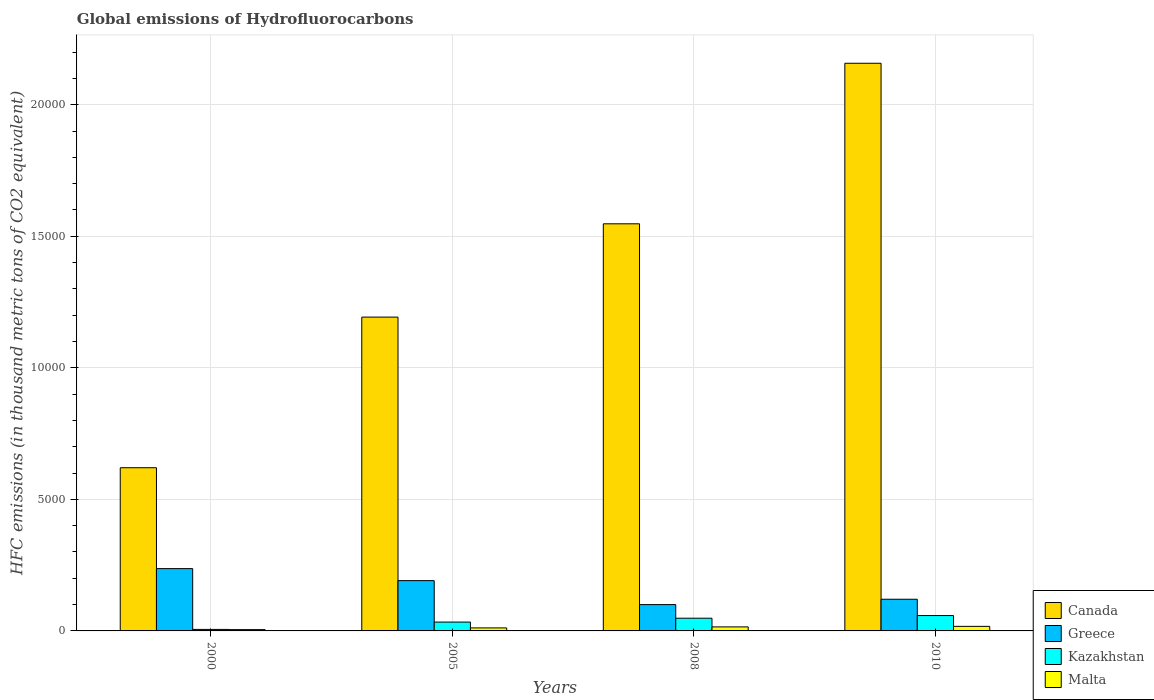Are the number of bars per tick equal to the number of legend labels?
Offer a terse response. Yes. Are the number of bars on each tick of the X-axis equal?
Offer a terse response. Yes. How many bars are there on the 3rd tick from the left?
Your answer should be very brief. 4. How many bars are there on the 2nd tick from the right?
Give a very brief answer. 4. In how many cases, is the number of bars for a given year not equal to the number of legend labels?
Give a very brief answer. 0. What is the global emissions of Hydrofluorocarbons in Kazakhstan in 2008?
Offer a terse response. 482.9. Across all years, what is the maximum global emissions of Hydrofluorocarbons in Canada?
Your response must be concise. 2.16e+04. Across all years, what is the minimum global emissions of Hydrofluorocarbons in Greece?
Your answer should be very brief. 1000.3. In which year was the global emissions of Hydrofluorocarbons in Greece maximum?
Offer a very short reply. 2000. In which year was the global emissions of Hydrofluorocarbons in Canada minimum?
Offer a terse response. 2000. What is the total global emissions of Hydrofluorocarbons in Kazakhstan in the graph?
Your response must be concise. 1461.1. What is the difference between the global emissions of Hydrofluorocarbons in Malta in 2005 and that in 2008?
Provide a succinct answer. -39. What is the difference between the global emissions of Hydrofluorocarbons in Canada in 2008 and the global emissions of Hydrofluorocarbons in Greece in 2000?
Offer a very short reply. 1.31e+04. What is the average global emissions of Hydrofluorocarbons in Malta per year?
Provide a short and direct response. 122.6. In the year 2000, what is the difference between the global emissions of Hydrofluorocarbons in Greece and global emissions of Hydrofluorocarbons in Malta?
Provide a short and direct response. 2318.4. What is the ratio of the global emissions of Hydrofluorocarbons in Kazakhstan in 2005 to that in 2008?
Your answer should be very brief. 0.7. Is the difference between the global emissions of Hydrofluorocarbons in Greece in 2000 and 2008 greater than the difference between the global emissions of Hydrofluorocarbons in Malta in 2000 and 2008?
Your response must be concise. Yes. What is the difference between the highest and the second highest global emissions of Hydrofluorocarbons in Malta?
Make the answer very short. 19.8. What is the difference between the highest and the lowest global emissions of Hydrofluorocarbons in Canada?
Give a very brief answer. 1.54e+04. In how many years, is the global emissions of Hydrofluorocarbons in Greece greater than the average global emissions of Hydrofluorocarbons in Greece taken over all years?
Offer a terse response. 2. Is the sum of the global emissions of Hydrofluorocarbons in Malta in 2005 and 2008 greater than the maximum global emissions of Hydrofluorocarbons in Canada across all years?
Offer a very short reply. No. What does the 4th bar from the left in 2005 represents?
Ensure brevity in your answer.  Malta. What does the 4th bar from the right in 2010 represents?
Ensure brevity in your answer.  Canada. Is it the case that in every year, the sum of the global emissions of Hydrofluorocarbons in Malta and global emissions of Hydrofluorocarbons in Greece is greater than the global emissions of Hydrofluorocarbons in Canada?
Offer a very short reply. No. How many bars are there?
Make the answer very short. 16. How many years are there in the graph?
Your answer should be compact. 4. Are the values on the major ticks of Y-axis written in scientific E-notation?
Your answer should be very brief. No. Does the graph contain any zero values?
Give a very brief answer. No. Where does the legend appear in the graph?
Make the answer very short. Bottom right. What is the title of the graph?
Offer a terse response. Global emissions of Hydrofluorocarbons. What is the label or title of the X-axis?
Provide a short and direct response. Years. What is the label or title of the Y-axis?
Your response must be concise. HFC emissions (in thousand metric tons of CO2 equivalent). What is the HFC emissions (in thousand metric tons of CO2 equivalent) of Canada in 2000?
Provide a short and direct response. 6202.8. What is the HFC emissions (in thousand metric tons of CO2 equivalent) in Greece in 2000?
Your answer should be very brief. 2368.4. What is the HFC emissions (in thousand metric tons of CO2 equivalent) of Kazakhstan in 2000?
Make the answer very short. 57.5. What is the HFC emissions (in thousand metric tons of CO2 equivalent) of Canada in 2005?
Keep it short and to the point. 1.19e+04. What is the HFC emissions (in thousand metric tons of CO2 equivalent) of Greece in 2005?
Give a very brief answer. 1911.4. What is the HFC emissions (in thousand metric tons of CO2 equivalent) of Kazakhstan in 2005?
Offer a terse response. 336.7. What is the HFC emissions (in thousand metric tons of CO2 equivalent) of Malta in 2005?
Your answer should be compact. 114.2. What is the HFC emissions (in thousand metric tons of CO2 equivalent) in Canada in 2008?
Provide a succinct answer. 1.55e+04. What is the HFC emissions (in thousand metric tons of CO2 equivalent) in Greece in 2008?
Provide a succinct answer. 1000.3. What is the HFC emissions (in thousand metric tons of CO2 equivalent) in Kazakhstan in 2008?
Provide a succinct answer. 482.9. What is the HFC emissions (in thousand metric tons of CO2 equivalent) of Malta in 2008?
Provide a succinct answer. 153.2. What is the HFC emissions (in thousand metric tons of CO2 equivalent) in Canada in 2010?
Keep it short and to the point. 2.16e+04. What is the HFC emissions (in thousand metric tons of CO2 equivalent) of Greece in 2010?
Give a very brief answer. 1204. What is the HFC emissions (in thousand metric tons of CO2 equivalent) in Kazakhstan in 2010?
Provide a short and direct response. 584. What is the HFC emissions (in thousand metric tons of CO2 equivalent) of Malta in 2010?
Make the answer very short. 173. Across all years, what is the maximum HFC emissions (in thousand metric tons of CO2 equivalent) of Canada?
Your answer should be compact. 2.16e+04. Across all years, what is the maximum HFC emissions (in thousand metric tons of CO2 equivalent) in Greece?
Provide a short and direct response. 2368.4. Across all years, what is the maximum HFC emissions (in thousand metric tons of CO2 equivalent) in Kazakhstan?
Keep it short and to the point. 584. Across all years, what is the maximum HFC emissions (in thousand metric tons of CO2 equivalent) in Malta?
Provide a short and direct response. 173. Across all years, what is the minimum HFC emissions (in thousand metric tons of CO2 equivalent) of Canada?
Your answer should be very brief. 6202.8. Across all years, what is the minimum HFC emissions (in thousand metric tons of CO2 equivalent) in Greece?
Keep it short and to the point. 1000.3. Across all years, what is the minimum HFC emissions (in thousand metric tons of CO2 equivalent) in Kazakhstan?
Give a very brief answer. 57.5. Across all years, what is the minimum HFC emissions (in thousand metric tons of CO2 equivalent) of Malta?
Keep it short and to the point. 50. What is the total HFC emissions (in thousand metric tons of CO2 equivalent) of Canada in the graph?
Provide a short and direct response. 5.52e+04. What is the total HFC emissions (in thousand metric tons of CO2 equivalent) of Greece in the graph?
Ensure brevity in your answer.  6484.1. What is the total HFC emissions (in thousand metric tons of CO2 equivalent) in Kazakhstan in the graph?
Provide a succinct answer. 1461.1. What is the total HFC emissions (in thousand metric tons of CO2 equivalent) of Malta in the graph?
Provide a short and direct response. 490.4. What is the difference between the HFC emissions (in thousand metric tons of CO2 equivalent) of Canada in 2000 and that in 2005?
Your response must be concise. -5725.6. What is the difference between the HFC emissions (in thousand metric tons of CO2 equivalent) in Greece in 2000 and that in 2005?
Offer a terse response. 457. What is the difference between the HFC emissions (in thousand metric tons of CO2 equivalent) in Kazakhstan in 2000 and that in 2005?
Your answer should be very brief. -279.2. What is the difference between the HFC emissions (in thousand metric tons of CO2 equivalent) of Malta in 2000 and that in 2005?
Provide a succinct answer. -64.2. What is the difference between the HFC emissions (in thousand metric tons of CO2 equivalent) in Canada in 2000 and that in 2008?
Provide a short and direct response. -9272. What is the difference between the HFC emissions (in thousand metric tons of CO2 equivalent) of Greece in 2000 and that in 2008?
Your response must be concise. 1368.1. What is the difference between the HFC emissions (in thousand metric tons of CO2 equivalent) in Kazakhstan in 2000 and that in 2008?
Provide a succinct answer. -425.4. What is the difference between the HFC emissions (in thousand metric tons of CO2 equivalent) of Malta in 2000 and that in 2008?
Offer a very short reply. -103.2. What is the difference between the HFC emissions (in thousand metric tons of CO2 equivalent) in Canada in 2000 and that in 2010?
Your answer should be compact. -1.54e+04. What is the difference between the HFC emissions (in thousand metric tons of CO2 equivalent) of Greece in 2000 and that in 2010?
Provide a succinct answer. 1164.4. What is the difference between the HFC emissions (in thousand metric tons of CO2 equivalent) in Kazakhstan in 2000 and that in 2010?
Offer a terse response. -526.5. What is the difference between the HFC emissions (in thousand metric tons of CO2 equivalent) in Malta in 2000 and that in 2010?
Offer a very short reply. -123. What is the difference between the HFC emissions (in thousand metric tons of CO2 equivalent) in Canada in 2005 and that in 2008?
Offer a terse response. -3546.4. What is the difference between the HFC emissions (in thousand metric tons of CO2 equivalent) in Greece in 2005 and that in 2008?
Offer a terse response. 911.1. What is the difference between the HFC emissions (in thousand metric tons of CO2 equivalent) in Kazakhstan in 2005 and that in 2008?
Provide a succinct answer. -146.2. What is the difference between the HFC emissions (in thousand metric tons of CO2 equivalent) of Malta in 2005 and that in 2008?
Provide a short and direct response. -39. What is the difference between the HFC emissions (in thousand metric tons of CO2 equivalent) of Canada in 2005 and that in 2010?
Your answer should be very brief. -9648.6. What is the difference between the HFC emissions (in thousand metric tons of CO2 equivalent) in Greece in 2005 and that in 2010?
Make the answer very short. 707.4. What is the difference between the HFC emissions (in thousand metric tons of CO2 equivalent) in Kazakhstan in 2005 and that in 2010?
Your answer should be very brief. -247.3. What is the difference between the HFC emissions (in thousand metric tons of CO2 equivalent) in Malta in 2005 and that in 2010?
Make the answer very short. -58.8. What is the difference between the HFC emissions (in thousand metric tons of CO2 equivalent) in Canada in 2008 and that in 2010?
Ensure brevity in your answer.  -6102.2. What is the difference between the HFC emissions (in thousand metric tons of CO2 equivalent) in Greece in 2008 and that in 2010?
Provide a succinct answer. -203.7. What is the difference between the HFC emissions (in thousand metric tons of CO2 equivalent) in Kazakhstan in 2008 and that in 2010?
Make the answer very short. -101.1. What is the difference between the HFC emissions (in thousand metric tons of CO2 equivalent) of Malta in 2008 and that in 2010?
Provide a succinct answer. -19.8. What is the difference between the HFC emissions (in thousand metric tons of CO2 equivalent) of Canada in 2000 and the HFC emissions (in thousand metric tons of CO2 equivalent) of Greece in 2005?
Offer a very short reply. 4291.4. What is the difference between the HFC emissions (in thousand metric tons of CO2 equivalent) of Canada in 2000 and the HFC emissions (in thousand metric tons of CO2 equivalent) of Kazakhstan in 2005?
Provide a short and direct response. 5866.1. What is the difference between the HFC emissions (in thousand metric tons of CO2 equivalent) of Canada in 2000 and the HFC emissions (in thousand metric tons of CO2 equivalent) of Malta in 2005?
Provide a succinct answer. 6088.6. What is the difference between the HFC emissions (in thousand metric tons of CO2 equivalent) of Greece in 2000 and the HFC emissions (in thousand metric tons of CO2 equivalent) of Kazakhstan in 2005?
Provide a succinct answer. 2031.7. What is the difference between the HFC emissions (in thousand metric tons of CO2 equivalent) of Greece in 2000 and the HFC emissions (in thousand metric tons of CO2 equivalent) of Malta in 2005?
Offer a very short reply. 2254.2. What is the difference between the HFC emissions (in thousand metric tons of CO2 equivalent) in Kazakhstan in 2000 and the HFC emissions (in thousand metric tons of CO2 equivalent) in Malta in 2005?
Your answer should be very brief. -56.7. What is the difference between the HFC emissions (in thousand metric tons of CO2 equivalent) of Canada in 2000 and the HFC emissions (in thousand metric tons of CO2 equivalent) of Greece in 2008?
Keep it short and to the point. 5202.5. What is the difference between the HFC emissions (in thousand metric tons of CO2 equivalent) in Canada in 2000 and the HFC emissions (in thousand metric tons of CO2 equivalent) in Kazakhstan in 2008?
Your response must be concise. 5719.9. What is the difference between the HFC emissions (in thousand metric tons of CO2 equivalent) of Canada in 2000 and the HFC emissions (in thousand metric tons of CO2 equivalent) of Malta in 2008?
Give a very brief answer. 6049.6. What is the difference between the HFC emissions (in thousand metric tons of CO2 equivalent) of Greece in 2000 and the HFC emissions (in thousand metric tons of CO2 equivalent) of Kazakhstan in 2008?
Your response must be concise. 1885.5. What is the difference between the HFC emissions (in thousand metric tons of CO2 equivalent) of Greece in 2000 and the HFC emissions (in thousand metric tons of CO2 equivalent) of Malta in 2008?
Provide a short and direct response. 2215.2. What is the difference between the HFC emissions (in thousand metric tons of CO2 equivalent) in Kazakhstan in 2000 and the HFC emissions (in thousand metric tons of CO2 equivalent) in Malta in 2008?
Your response must be concise. -95.7. What is the difference between the HFC emissions (in thousand metric tons of CO2 equivalent) in Canada in 2000 and the HFC emissions (in thousand metric tons of CO2 equivalent) in Greece in 2010?
Your response must be concise. 4998.8. What is the difference between the HFC emissions (in thousand metric tons of CO2 equivalent) of Canada in 2000 and the HFC emissions (in thousand metric tons of CO2 equivalent) of Kazakhstan in 2010?
Your answer should be very brief. 5618.8. What is the difference between the HFC emissions (in thousand metric tons of CO2 equivalent) of Canada in 2000 and the HFC emissions (in thousand metric tons of CO2 equivalent) of Malta in 2010?
Make the answer very short. 6029.8. What is the difference between the HFC emissions (in thousand metric tons of CO2 equivalent) of Greece in 2000 and the HFC emissions (in thousand metric tons of CO2 equivalent) of Kazakhstan in 2010?
Keep it short and to the point. 1784.4. What is the difference between the HFC emissions (in thousand metric tons of CO2 equivalent) of Greece in 2000 and the HFC emissions (in thousand metric tons of CO2 equivalent) of Malta in 2010?
Ensure brevity in your answer.  2195.4. What is the difference between the HFC emissions (in thousand metric tons of CO2 equivalent) in Kazakhstan in 2000 and the HFC emissions (in thousand metric tons of CO2 equivalent) in Malta in 2010?
Keep it short and to the point. -115.5. What is the difference between the HFC emissions (in thousand metric tons of CO2 equivalent) in Canada in 2005 and the HFC emissions (in thousand metric tons of CO2 equivalent) in Greece in 2008?
Provide a succinct answer. 1.09e+04. What is the difference between the HFC emissions (in thousand metric tons of CO2 equivalent) of Canada in 2005 and the HFC emissions (in thousand metric tons of CO2 equivalent) of Kazakhstan in 2008?
Offer a terse response. 1.14e+04. What is the difference between the HFC emissions (in thousand metric tons of CO2 equivalent) of Canada in 2005 and the HFC emissions (in thousand metric tons of CO2 equivalent) of Malta in 2008?
Your answer should be compact. 1.18e+04. What is the difference between the HFC emissions (in thousand metric tons of CO2 equivalent) of Greece in 2005 and the HFC emissions (in thousand metric tons of CO2 equivalent) of Kazakhstan in 2008?
Offer a very short reply. 1428.5. What is the difference between the HFC emissions (in thousand metric tons of CO2 equivalent) in Greece in 2005 and the HFC emissions (in thousand metric tons of CO2 equivalent) in Malta in 2008?
Make the answer very short. 1758.2. What is the difference between the HFC emissions (in thousand metric tons of CO2 equivalent) of Kazakhstan in 2005 and the HFC emissions (in thousand metric tons of CO2 equivalent) of Malta in 2008?
Provide a short and direct response. 183.5. What is the difference between the HFC emissions (in thousand metric tons of CO2 equivalent) of Canada in 2005 and the HFC emissions (in thousand metric tons of CO2 equivalent) of Greece in 2010?
Your answer should be compact. 1.07e+04. What is the difference between the HFC emissions (in thousand metric tons of CO2 equivalent) in Canada in 2005 and the HFC emissions (in thousand metric tons of CO2 equivalent) in Kazakhstan in 2010?
Offer a very short reply. 1.13e+04. What is the difference between the HFC emissions (in thousand metric tons of CO2 equivalent) of Canada in 2005 and the HFC emissions (in thousand metric tons of CO2 equivalent) of Malta in 2010?
Offer a very short reply. 1.18e+04. What is the difference between the HFC emissions (in thousand metric tons of CO2 equivalent) of Greece in 2005 and the HFC emissions (in thousand metric tons of CO2 equivalent) of Kazakhstan in 2010?
Give a very brief answer. 1327.4. What is the difference between the HFC emissions (in thousand metric tons of CO2 equivalent) of Greece in 2005 and the HFC emissions (in thousand metric tons of CO2 equivalent) of Malta in 2010?
Provide a short and direct response. 1738.4. What is the difference between the HFC emissions (in thousand metric tons of CO2 equivalent) of Kazakhstan in 2005 and the HFC emissions (in thousand metric tons of CO2 equivalent) of Malta in 2010?
Keep it short and to the point. 163.7. What is the difference between the HFC emissions (in thousand metric tons of CO2 equivalent) of Canada in 2008 and the HFC emissions (in thousand metric tons of CO2 equivalent) of Greece in 2010?
Provide a succinct answer. 1.43e+04. What is the difference between the HFC emissions (in thousand metric tons of CO2 equivalent) in Canada in 2008 and the HFC emissions (in thousand metric tons of CO2 equivalent) in Kazakhstan in 2010?
Your answer should be very brief. 1.49e+04. What is the difference between the HFC emissions (in thousand metric tons of CO2 equivalent) in Canada in 2008 and the HFC emissions (in thousand metric tons of CO2 equivalent) in Malta in 2010?
Give a very brief answer. 1.53e+04. What is the difference between the HFC emissions (in thousand metric tons of CO2 equivalent) in Greece in 2008 and the HFC emissions (in thousand metric tons of CO2 equivalent) in Kazakhstan in 2010?
Keep it short and to the point. 416.3. What is the difference between the HFC emissions (in thousand metric tons of CO2 equivalent) of Greece in 2008 and the HFC emissions (in thousand metric tons of CO2 equivalent) of Malta in 2010?
Make the answer very short. 827.3. What is the difference between the HFC emissions (in thousand metric tons of CO2 equivalent) in Kazakhstan in 2008 and the HFC emissions (in thousand metric tons of CO2 equivalent) in Malta in 2010?
Make the answer very short. 309.9. What is the average HFC emissions (in thousand metric tons of CO2 equivalent) of Canada per year?
Your answer should be compact. 1.38e+04. What is the average HFC emissions (in thousand metric tons of CO2 equivalent) in Greece per year?
Ensure brevity in your answer.  1621.03. What is the average HFC emissions (in thousand metric tons of CO2 equivalent) in Kazakhstan per year?
Give a very brief answer. 365.27. What is the average HFC emissions (in thousand metric tons of CO2 equivalent) of Malta per year?
Make the answer very short. 122.6. In the year 2000, what is the difference between the HFC emissions (in thousand metric tons of CO2 equivalent) in Canada and HFC emissions (in thousand metric tons of CO2 equivalent) in Greece?
Your answer should be compact. 3834.4. In the year 2000, what is the difference between the HFC emissions (in thousand metric tons of CO2 equivalent) in Canada and HFC emissions (in thousand metric tons of CO2 equivalent) in Kazakhstan?
Provide a succinct answer. 6145.3. In the year 2000, what is the difference between the HFC emissions (in thousand metric tons of CO2 equivalent) in Canada and HFC emissions (in thousand metric tons of CO2 equivalent) in Malta?
Offer a very short reply. 6152.8. In the year 2000, what is the difference between the HFC emissions (in thousand metric tons of CO2 equivalent) of Greece and HFC emissions (in thousand metric tons of CO2 equivalent) of Kazakhstan?
Give a very brief answer. 2310.9. In the year 2000, what is the difference between the HFC emissions (in thousand metric tons of CO2 equivalent) of Greece and HFC emissions (in thousand metric tons of CO2 equivalent) of Malta?
Give a very brief answer. 2318.4. In the year 2005, what is the difference between the HFC emissions (in thousand metric tons of CO2 equivalent) in Canada and HFC emissions (in thousand metric tons of CO2 equivalent) in Greece?
Provide a succinct answer. 1.00e+04. In the year 2005, what is the difference between the HFC emissions (in thousand metric tons of CO2 equivalent) in Canada and HFC emissions (in thousand metric tons of CO2 equivalent) in Kazakhstan?
Offer a terse response. 1.16e+04. In the year 2005, what is the difference between the HFC emissions (in thousand metric tons of CO2 equivalent) in Canada and HFC emissions (in thousand metric tons of CO2 equivalent) in Malta?
Your response must be concise. 1.18e+04. In the year 2005, what is the difference between the HFC emissions (in thousand metric tons of CO2 equivalent) in Greece and HFC emissions (in thousand metric tons of CO2 equivalent) in Kazakhstan?
Offer a terse response. 1574.7. In the year 2005, what is the difference between the HFC emissions (in thousand metric tons of CO2 equivalent) of Greece and HFC emissions (in thousand metric tons of CO2 equivalent) of Malta?
Your response must be concise. 1797.2. In the year 2005, what is the difference between the HFC emissions (in thousand metric tons of CO2 equivalent) in Kazakhstan and HFC emissions (in thousand metric tons of CO2 equivalent) in Malta?
Keep it short and to the point. 222.5. In the year 2008, what is the difference between the HFC emissions (in thousand metric tons of CO2 equivalent) of Canada and HFC emissions (in thousand metric tons of CO2 equivalent) of Greece?
Make the answer very short. 1.45e+04. In the year 2008, what is the difference between the HFC emissions (in thousand metric tons of CO2 equivalent) of Canada and HFC emissions (in thousand metric tons of CO2 equivalent) of Kazakhstan?
Your response must be concise. 1.50e+04. In the year 2008, what is the difference between the HFC emissions (in thousand metric tons of CO2 equivalent) of Canada and HFC emissions (in thousand metric tons of CO2 equivalent) of Malta?
Give a very brief answer. 1.53e+04. In the year 2008, what is the difference between the HFC emissions (in thousand metric tons of CO2 equivalent) in Greece and HFC emissions (in thousand metric tons of CO2 equivalent) in Kazakhstan?
Provide a short and direct response. 517.4. In the year 2008, what is the difference between the HFC emissions (in thousand metric tons of CO2 equivalent) of Greece and HFC emissions (in thousand metric tons of CO2 equivalent) of Malta?
Give a very brief answer. 847.1. In the year 2008, what is the difference between the HFC emissions (in thousand metric tons of CO2 equivalent) in Kazakhstan and HFC emissions (in thousand metric tons of CO2 equivalent) in Malta?
Provide a short and direct response. 329.7. In the year 2010, what is the difference between the HFC emissions (in thousand metric tons of CO2 equivalent) of Canada and HFC emissions (in thousand metric tons of CO2 equivalent) of Greece?
Offer a very short reply. 2.04e+04. In the year 2010, what is the difference between the HFC emissions (in thousand metric tons of CO2 equivalent) of Canada and HFC emissions (in thousand metric tons of CO2 equivalent) of Kazakhstan?
Your answer should be compact. 2.10e+04. In the year 2010, what is the difference between the HFC emissions (in thousand metric tons of CO2 equivalent) of Canada and HFC emissions (in thousand metric tons of CO2 equivalent) of Malta?
Your answer should be very brief. 2.14e+04. In the year 2010, what is the difference between the HFC emissions (in thousand metric tons of CO2 equivalent) in Greece and HFC emissions (in thousand metric tons of CO2 equivalent) in Kazakhstan?
Make the answer very short. 620. In the year 2010, what is the difference between the HFC emissions (in thousand metric tons of CO2 equivalent) of Greece and HFC emissions (in thousand metric tons of CO2 equivalent) of Malta?
Offer a very short reply. 1031. In the year 2010, what is the difference between the HFC emissions (in thousand metric tons of CO2 equivalent) of Kazakhstan and HFC emissions (in thousand metric tons of CO2 equivalent) of Malta?
Your answer should be very brief. 411. What is the ratio of the HFC emissions (in thousand metric tons of CO2 equivalent) in Canada in 2000 to that in 2005?
Offer a very short reply. 0.52. What is the ratio of the HFC emissions (in thousand metric tons of CO2 equivalent) of Greece in 2000 to that in 2005?
Make the answer very short. 1.24. What is the ratio of the HFC emissions (in thousand metric tons of CO2 equivalent) of Kazakhstan in 2000 to that in 2005?
Provide a succinct answer. 0.17. What is the ratio of the HFC emissions (in thousand metric tons of CO2 equivalent) of Malta in 2000 to that in 2005?
Offer a very short reply. 0.44. What is the ratio of the HFC emissions (in thousand metric tons of CO2 equivalent) in Canada in 2000 to that in 2008?
Your answer should be compact. 0.4. What is the ratio of the HFC emissions (in thousand metric tons of CO2 equivalent) in Greece in 2000 to that in 2008?
Offer a very short reply. 2.37. What is the ratio of the HFC emissions (in thousand metric tons of CO2 equivalent) of Kazakhstan in 2000 to that in 2008?
Offer a terse response. 0.12. What is the ratio of the HFC emissions (in thousand metric tons of CO2 equivalent) of Malta in 2000 to that in 2008?
Offer a terse response. 0.33. What is the ratio of the HFC emissions (in thousand metric tons of CO2 equivalent) of Canada in 2000 to that in 2010?
Offer a very short reply. 0.29. What is the ratio of the HFC emissions (in thousand metric tons of CO2 equivalent) in Greece in 2000 to that in 2010?
Your answer should be very brief. 1.97. What is the ratio of the HFC emissions (in thousand metric tons of CO2 equivalent) in Kazakhstan in 2000 to that in 2010?
Keep it short and to the point. 0.1. What is the ratio of the HFC emissions (in thousand metric tons of CO2 equivalent) of Malta in 2000 to that in 2010?
Make the answer very short. 0.29. What is the ratio of the HFC emissions (in thousand metric tons of CO2 equivalent) of Canada in 2005 to that in 2008?
Your response must be concise. 0.77. What is the ratio of the HFC emissions (in thousand metric tons of CO2 equivalent) in Greece in 2005 to that in 2008?
Make the answer very short. 1.91. What is the ratio of the HFC emissions (in thousand metric tons of CO2 equivalent) of Kazakhstan in 2005 to that in 2008?
Provide a succinct answer. 0.7. What is the ratio of the HFC emissions (in thousand metric tons of CO2 equivalent) of Malta in 2005 to that in 2008?
Keep it short and to the point. 0.75. What is the ratio of the HFC emissions (in thousand metric tons of CO2 equivalent) of Canada in 2005 to that in 2010?
Your response must be concise. 0.55. What is the ratio of the HFC emissions (in thousand metric tons of CO2 equivalent) in Greece in 2005 to that in 2010?
Give a very brief answer. 1.59. What is the ratio of the HFC emissions (in thousand metric tons of CO2 equivalent) of Kazakhstan in 2005 to that in 2010?
Offer a very short reply. 0.58. What is the ratio of the HFC emissions (in thousand metric tons of CO2 equivalent) of Malta in 2005 to that in 2010?
Keep it short and to the point. 0.66. What is the ratio of the HFC emissions (in thousand metric tons of CO2 equivalent) of Canada in 2008 to that in 2010?
Offer a very short reply. 0.72. What is the ratio of the HFC emissions (in thousand metric tons of CO2 equivalent) of Greece in 2008 to that in 2010?
Your response must be concise. 0.83. What is the ratio of the HFC emissions (in thousand metric tons of CO2 equivalent) in Kazakhstan in 2008 to that in 2010?
Ensure brevity in your answer.  0.83. What is the ratio of the HFC emissions (in thousand metric tons of CO2 equivalent) in Malta in 2008 to that in 2010?
Offer a terse response. 0.89. What is the difference between the highest and the second highest HFC emissions (in thousand metric tons of CO2 equivalent) in Canada?
Your answer should be very brief. 6102.2. What is the difference between the highest and the second highest HFC emissions (in thousand metric tons of CO2 equivalent) in Greece?
Provide a succinct answer. 457. What is the difference between the highest and the second highest HFC emissions (in thousand metric tons of CO2 equivalent) in Kazakhstan?
Provide a succinct answer. 101.1. What is the difference between the highest and the second highest HFC emissions (in thousand metric tons of CO2 equivalent) of Malta?
Ensure brevity in your answer.  19.8. What is the difference between the highest and the lowest HFC emissions (in thousand metric tons of CO2 equivalent) of Canada?
Make the answer very short. 1.54e+04. What is the difference between the highest and the lowest HFC emissions (in thousand metric tons of CO2 equivalent) in Greece?
Your answer should be compact. 1368.1. What is the difference between the highest and the lowest HFC emissions (in thousand metric tons of CO2 equivalent) of Kazakhstan?
Ensure brevity in your answer.  526.5. What is the difference between the highest and the lowest HFC emissions (in thousand metric tons of CO2 equivalent) of Malta?
Keep it short and to the point. 123. 